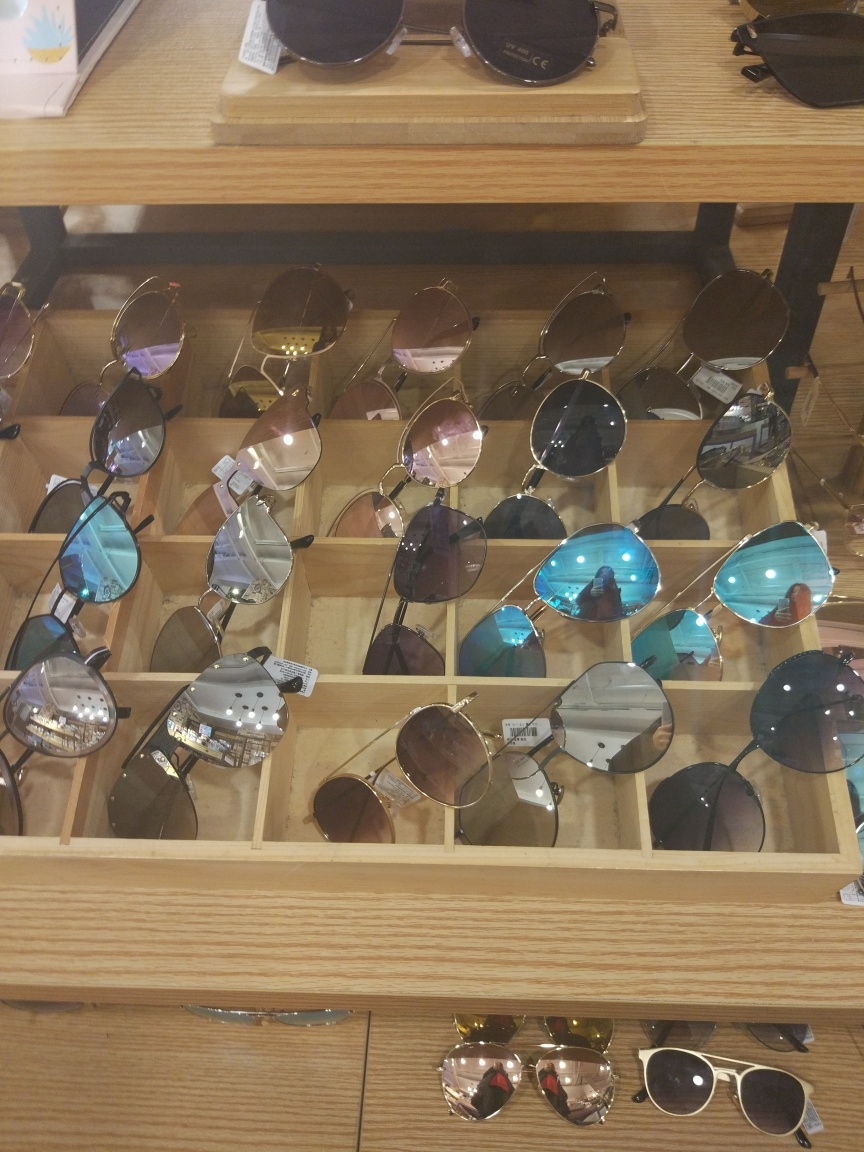Are there any quality issues with this image? The image has a slight blur, which affects the sharpness of the sunglasses on display. Additionally, the angle of the photo and lighting conditions create reflections on the lenses, which may obscure details. Improving the focus, reducing glare, and selecting a better angle could enhance the image quality. 